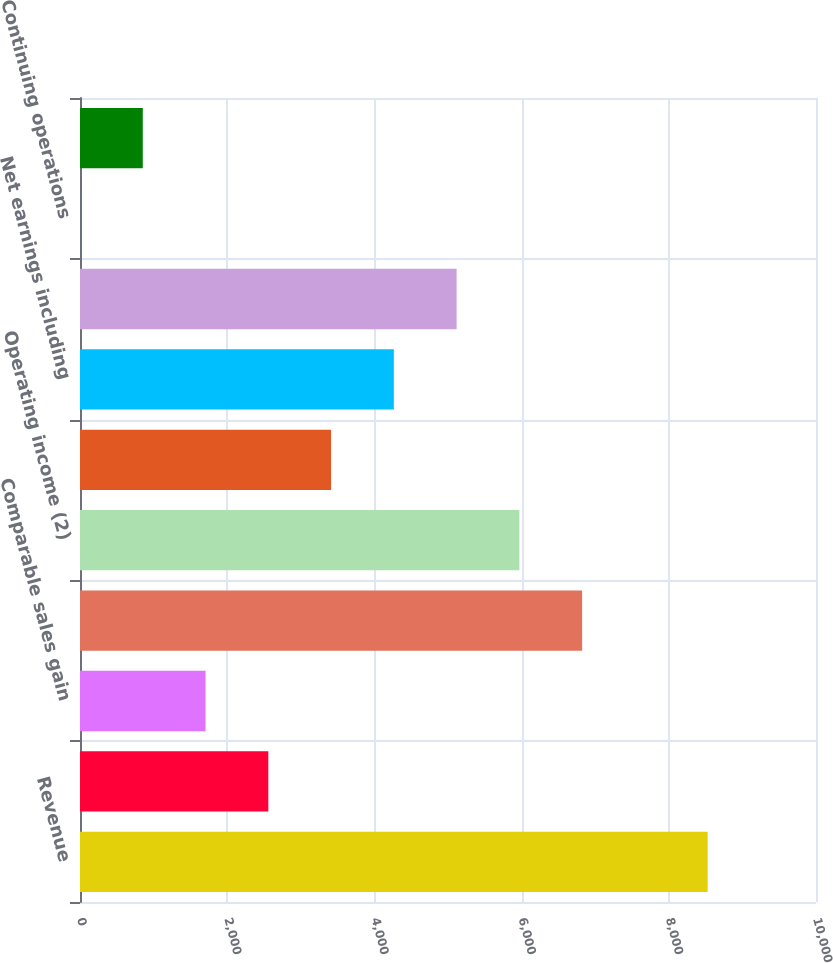Convert chart. <chart><loc_0><loc_0><loc_500><loc_500><bar_chart><fcel>Revenue<fcel>Comparable sales change (1)<fcel>Comparable sales gain<fcel>Gross profit<fcel>Operating income (2)<fcel>Net earnings from continuing<fcel>Net earnings including<fcel>Net earnings attributable to<fcel>Continuing operations<fcel>Diluted earnings per share<nl><fcel>8528<fcel>2558.71<fcel>1705.96<fcel>6822.46<fcel>5969.71<fcel>3411.46<fcel>4264.21<fcel>5116.96<fcel>0.46<fcel>853.21<nl></chart> 